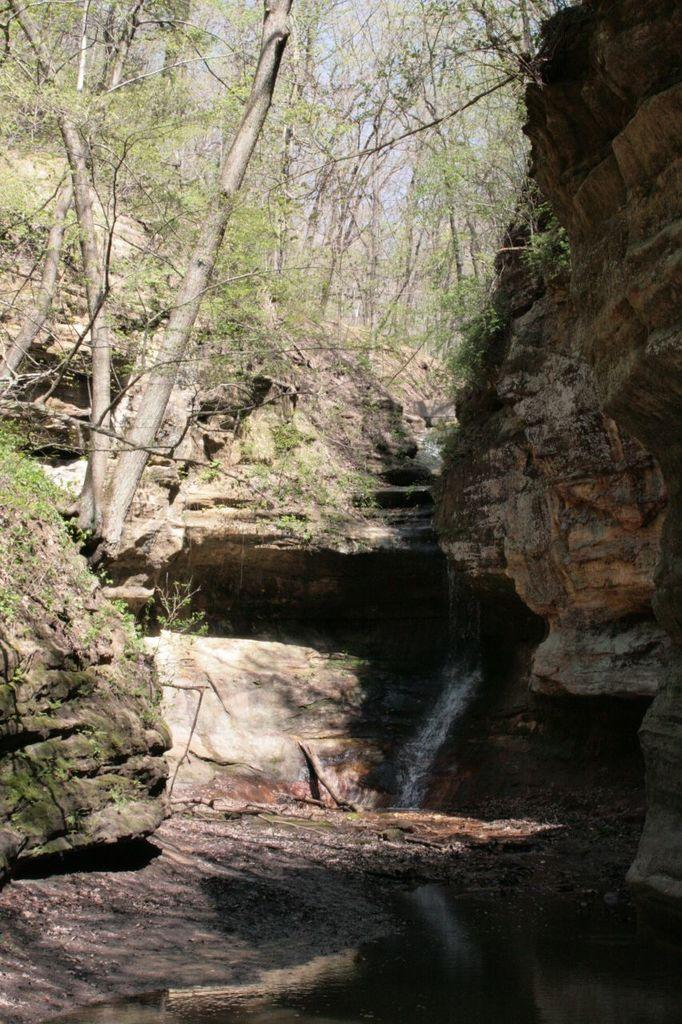What is the main feature of the image? There is a waterfall in the image. What can be seen in the background of the image? There are trees in the background of the image. Can you see someone kicking a soccer ball near the waterfall in the image? There is no soccer ball or person kicking it present in the image. What type of apple is growing on the trees in the background of the image? There are no apples visible on the trees in the image; only trees are present in the background. 